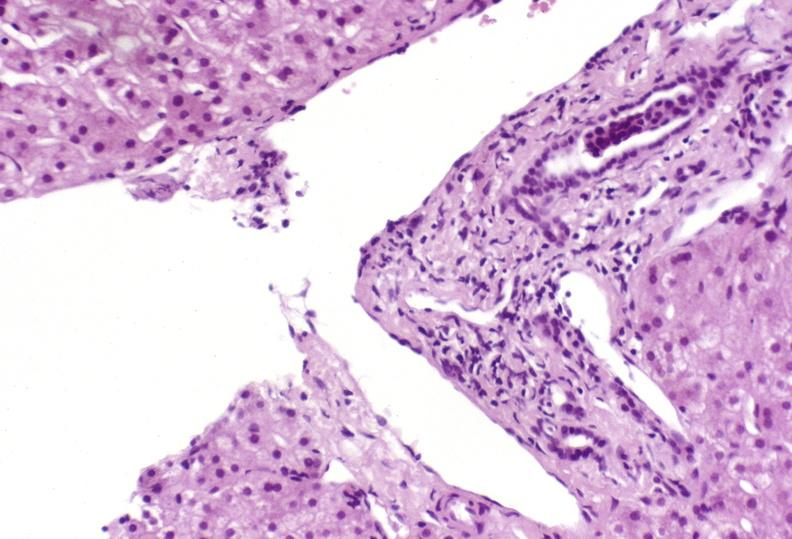s hepatobiliary present?
Answer the question using a single word or phrase. Yes 